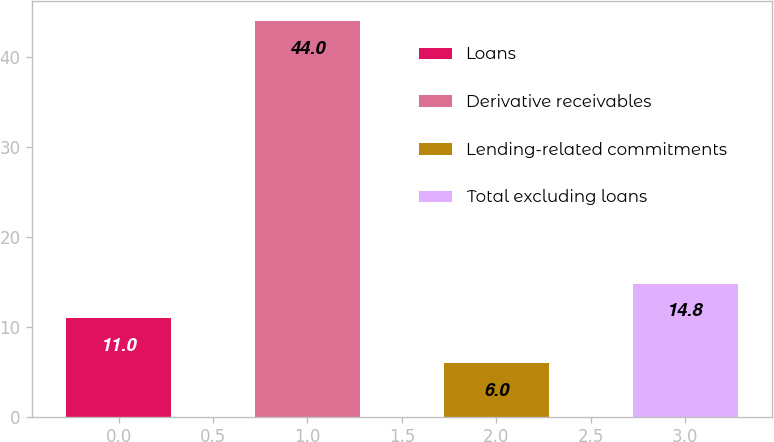Convert chart to OTSL. <chart><loc_0><loc_0><loc_500><loc_500><bar_chart><fcel>Loans<fcel>Derivative receivables<fcel>Lending-related commitments<fcel>Total excluding loans<nl><fcel>11<fcel>44<fcel>6<fcel>14.8<nl></chart> 